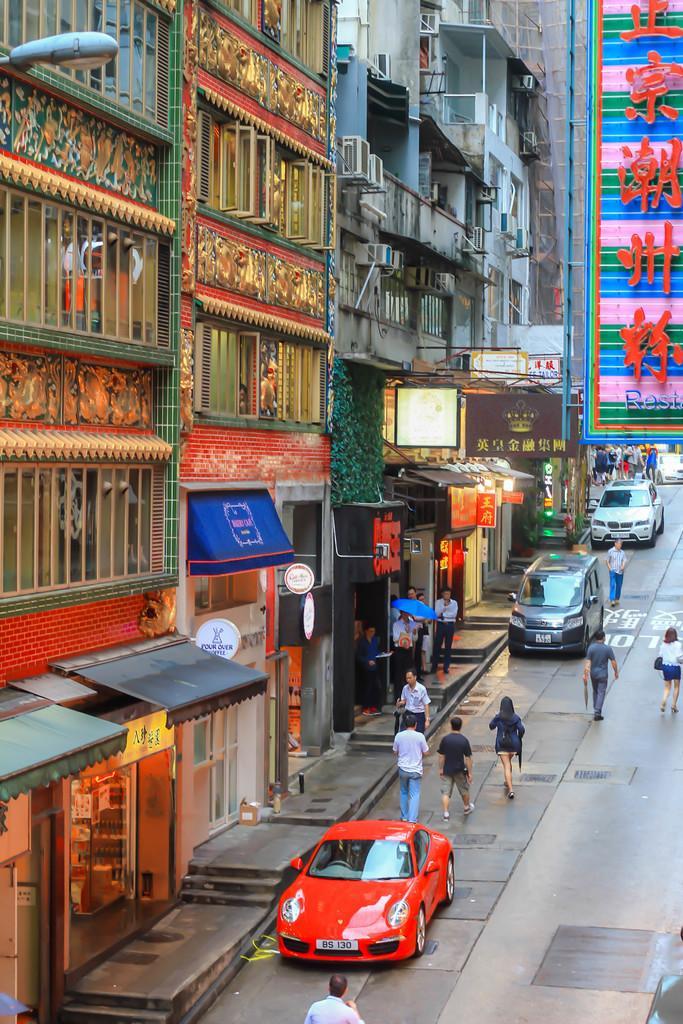Could you give a brief overview of what you see in this image? In this picture I can see many peoples who are walking on the street. Beside them I can see the cars which are parked in front of the shops. On the left I can see many buildings. On the right I can see the advertisement board. 